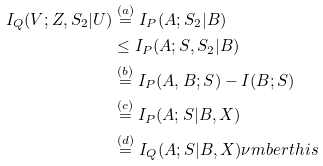Convert formula to latex. <formula><loc_0><loc_0><loc_500><loc_500>I _ { Q } ( V ; Z , S _ { 2 } | U ) & \stackrel { ( a ) } = I _ { P } ( A ; S _ { 2 } | B ) \\ & \leq I _ { P } ( A ; S , S _ { 2 } | B ) \\ & \stackrel { ( b ) } = I _ { P } ( A , B ; S ) - I ( B ; S ) \\ & \stackrel { ( c ) } = I _ { P } ( A ; S | B , X ) \\ & \stackrel { ( d ) } = I _ { Q } ( A ; S | B , X ) \nu m b e r t h i s</formula> 